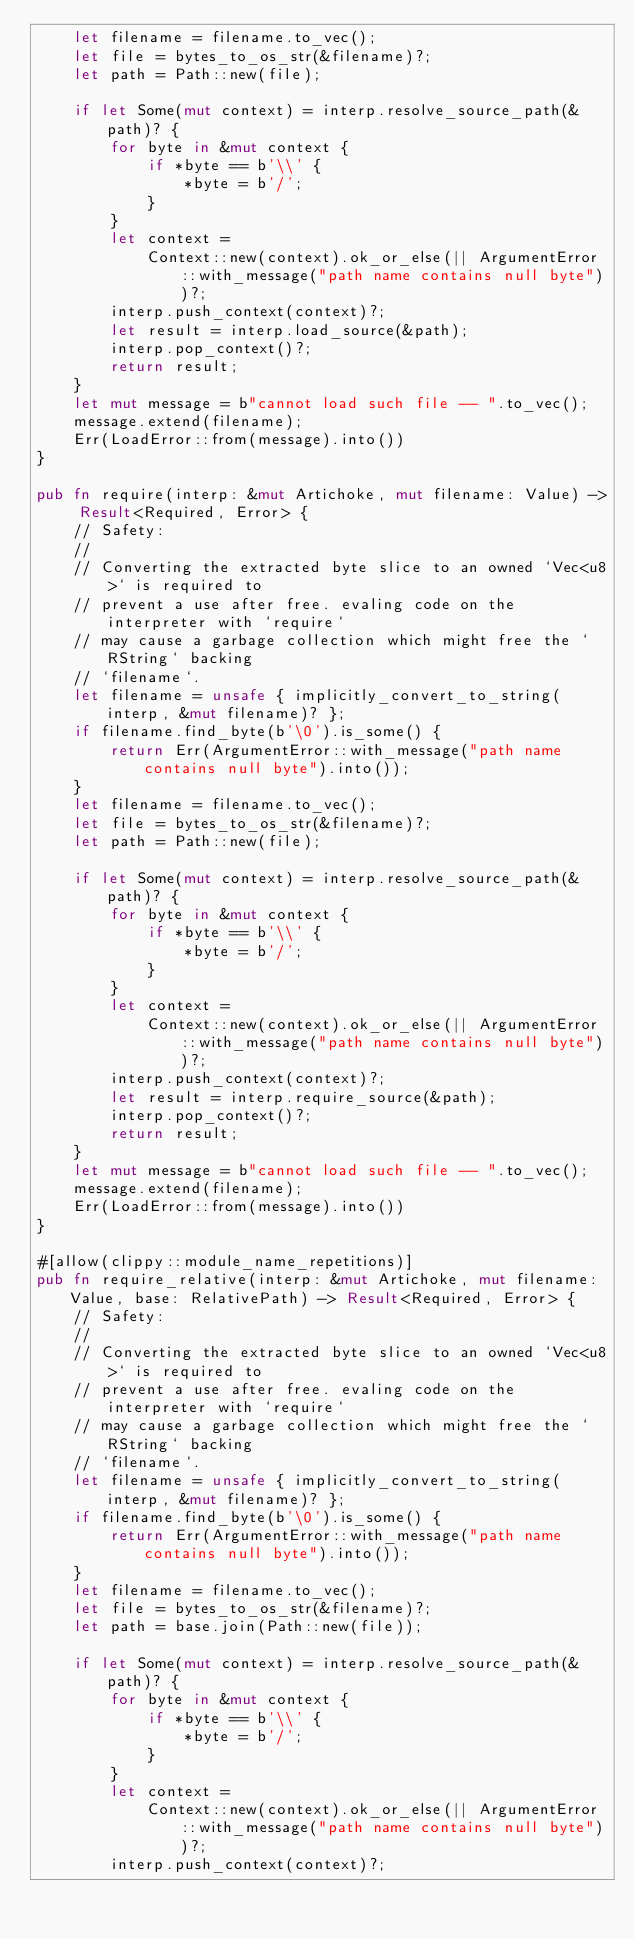<code> <loc_0><loc_0><loc_500><loc_500><_Rust_>    let filename = filename.to_vec();
    let file = bytes_to_os_str(&filename)?;
    let path = Path::new(file);

    if let Some(mut context) = interp.resolve_source_path(&path)? {
        for byte in &mut context {
            if *byte == b'\\' {
                *byte = b'/';
            }
        }
        let context =
            Context::new(context).ok_or_else(|| ArgumentError::with_message("path name contains null byte"))?;
        interp.push_context(context)?;
        let result = interp.load_source(&path);
        interp.pop_context()?;
        return result;
    }
    let mut message = b"cannot load such file -- ".to_vec();
    message.extend(filename);
    Err(LoadError::from(message).into())
}

pub fn require(interp: &mut Artichoke, mut filename: Value) -> Result<Required, Error> {
    // Safety:
    //
    // Converting the extracted byte slice to an owned `Vec<u8>` is required to
    // prevent a use after free. evaling code on the interpreter with `require`
    // may cause a garbage collection which might free the `RString` backing
    // `filename`.
    let filename = unsafe { implicitly_convert_to_string(interp, &mut filename)? };
    if filename.find_byte(b'\0').is_some() {
        return Err(ArgumentError::with_message("path name contains null byte").into());
    }
    let filename = filename.to_vec();
    let file = bytes_to_os_str(&filename)?;
    let path = Path::new(file);

    if let Some(mut context) = interp.resolve_source_path(&path)? {
        for byte in &mut context {
            if *byte == b'\\' {
                *byte = b'/';
            }
        }
        let context =
            Context::new(context).ok_or_else(|| ArgumentError::with_message("path name contains null byte"))?;
        interp.push_context(context)?;
        let result = interp.require_source(&path);
        interp.pop_context()?;
        return result;
    }
    let mut message = b"cannot load such file -- ".to_vec();
    message.extend(filename);
    Err(LoadError::from(message).into())
}

#[allow(clippy::module_name_repetitions)]
pub fn require_relative(interp: &mut Artichoke, mut filename: Value, base: RelativePath) -> Result<Required, Error> {
    // Safety:
    //
    // Converting the extracted byte slice to an owned `Vec<u8>` is required to
    // prevent a use after free. evaling code on the interpreter with `require`
    // may cause a garbage collection which might free the `RString` backing
    // `filename`.
    let filename = unsafe { implicitly_convert_to_string(interp, &mut filename)? };
    if filename.find_byte(b'\0').is_some() {
        return Err(ArgumentError::with_message("path name contains null byte").into());
    }
    let filename = filename.to_vec();
    let file = bytes_to_os_str(&filename)?;
    let path = base.join(Path::new(file));

    if let Some(mut context) = interp.resolve_source_path(&path)? {
        for byte in &mut context {
            if *byte == b'\\' {
                *byte = b'/';
            }
        }
        let context =
            Context::new(context).ok_or_else(|| ArgumentError::with_message("path name contains null byte"))?;
        interp.push_context(context)?;</code> 